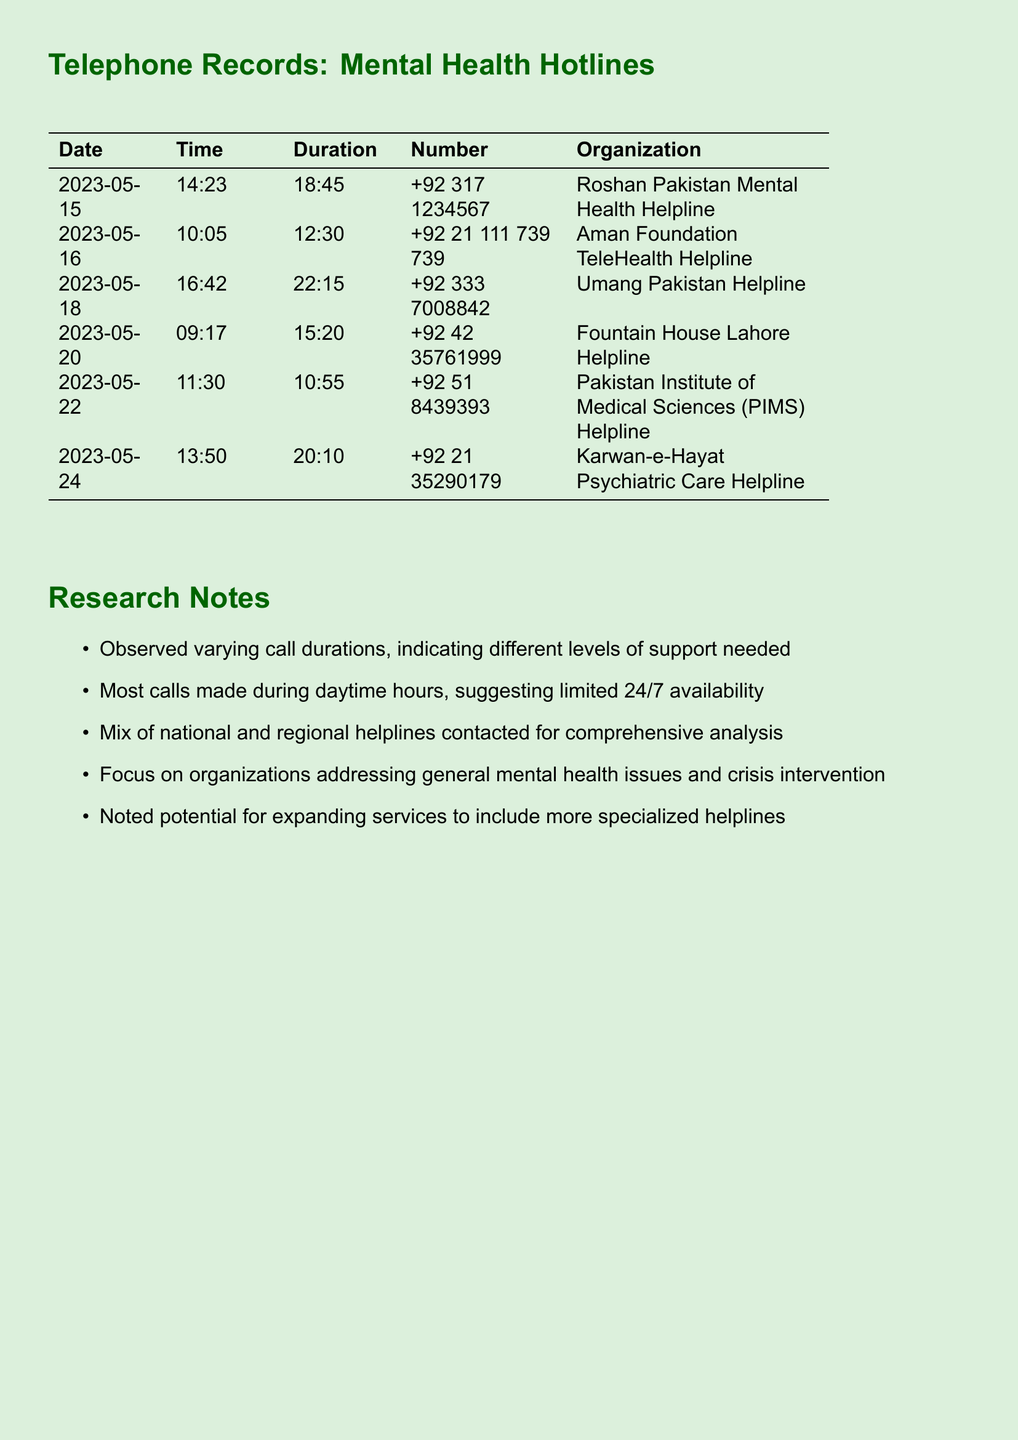What is the date of the first call? The first call listed is on May 15, 2023.
Answer: May 15, 2023 What is the duration of the call to the Aman Foundation TeleHealth Helpline? The duration of the call to this helpline is specific to the entry made on May 16, 2023.
Answer: 12:30 Which organization had the longest call duration? The document shows that the Umang Pakistan Helpline call was the longest.
Answer: Umang Pakistan Helpline How many helplines were contacted in total? The document lists each helpline and provides a count of them in the table.
Answer: 6 What is the contact number for the Roshan Pakistan Mental Health Helpline? The document provides the specific number under this organization's entry.
Answer: +92 317 1234567 During which time of day were most calls made? The analysis notes that calls were primarily made during the daytime hours.
Answer: Daytime What are some observations noted in the research notes? The notes include various observations about call durations and service availability.
Answer: Varying call durations Which helpline was contacted on May 22, 2023? The table provides specific information about each call, including the date and corresponding helpline.
Answer: Pakistan Institute of Medical Sciences (PIMS) Helpline 